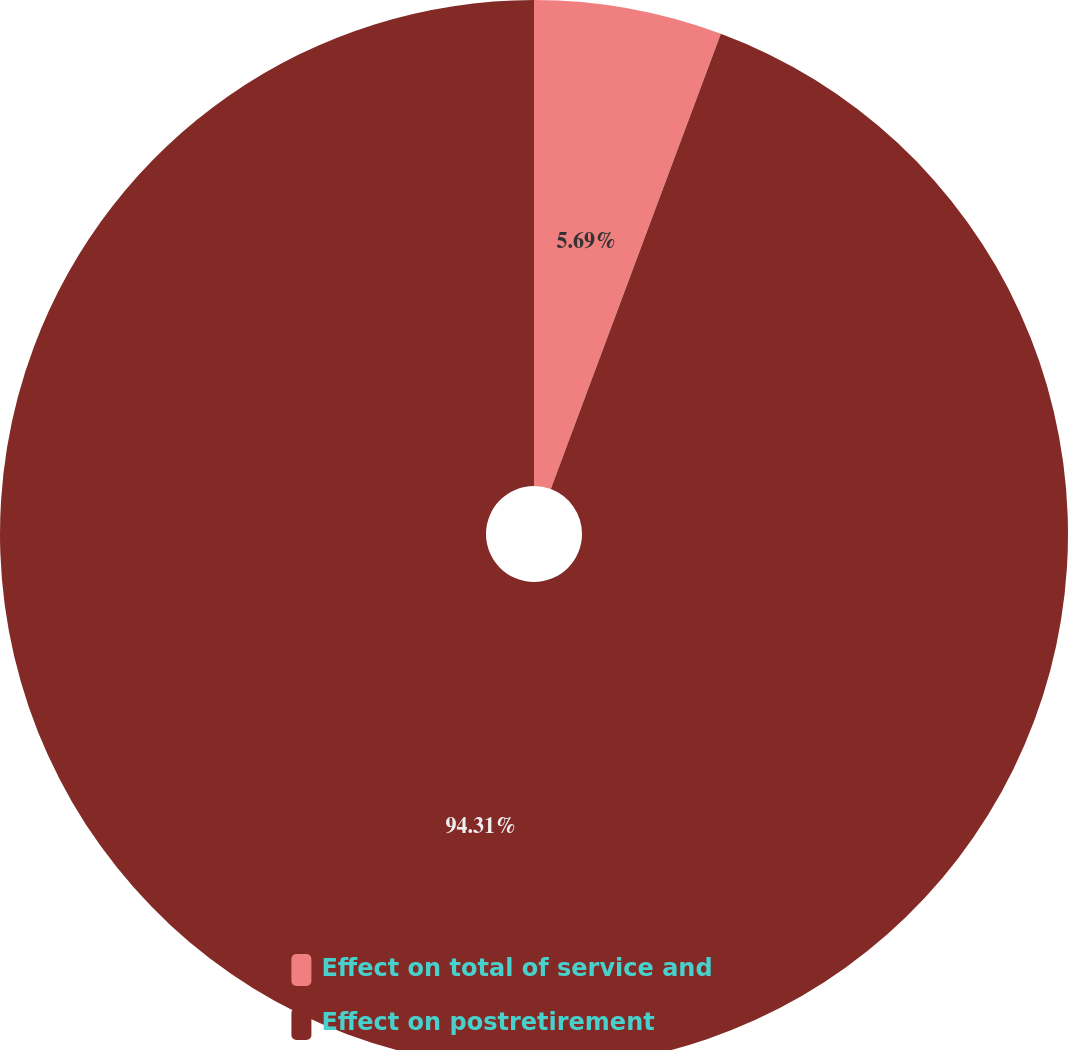Convert chart to OTSL. <chart><loc_0><loc_0><loc_500><loc_500><pie_chart><fcel>Effect on total of service and<fcel>Effect on postretirement<nl><fcel>5.69%<fcel>94.31%<nl></chart> 